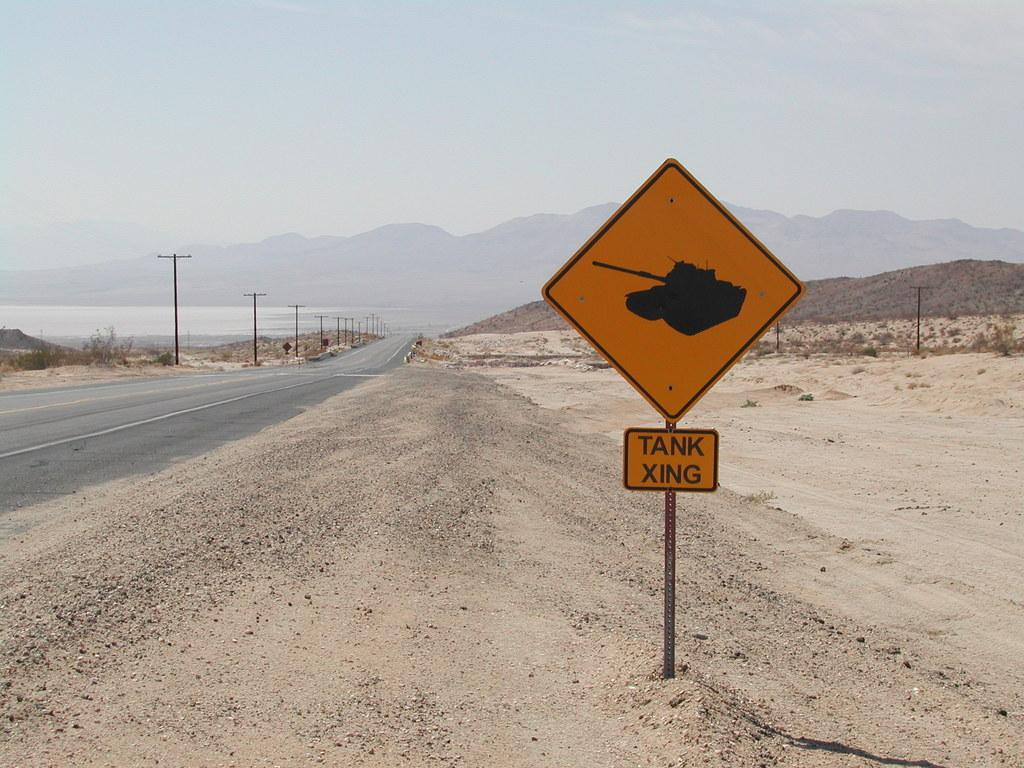<image>
Render a clear and concise summary of the photo. a yellow sign that has the word tank on it 